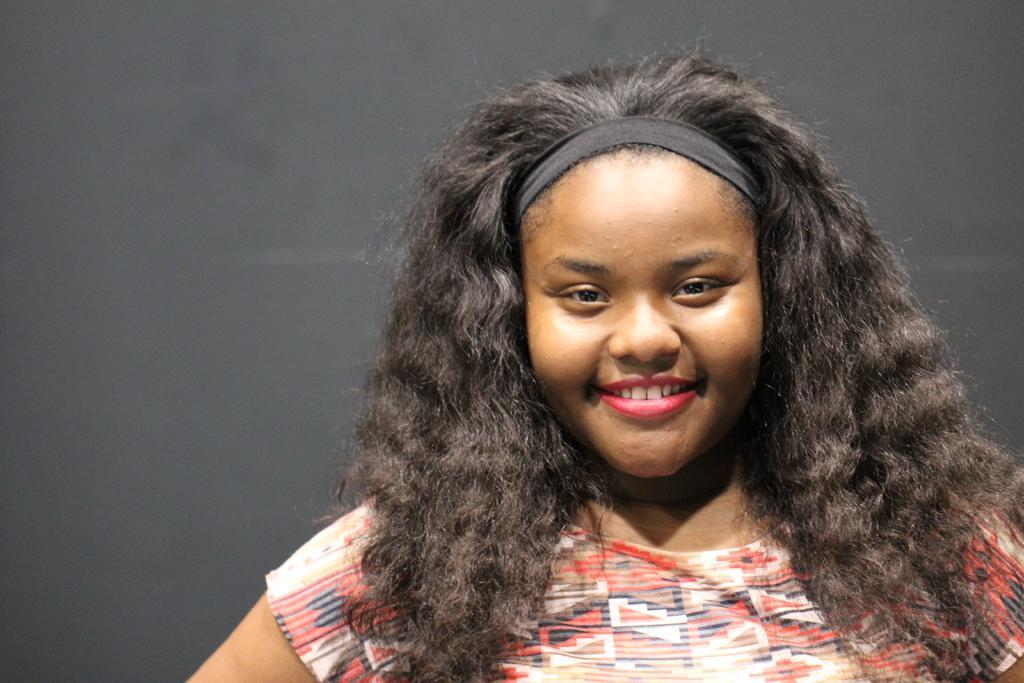Describe this image in one or two sentences. In the center of the image we can see a girl is smiling and wearing a T-shirt. In the background of the image we can see the wall. 